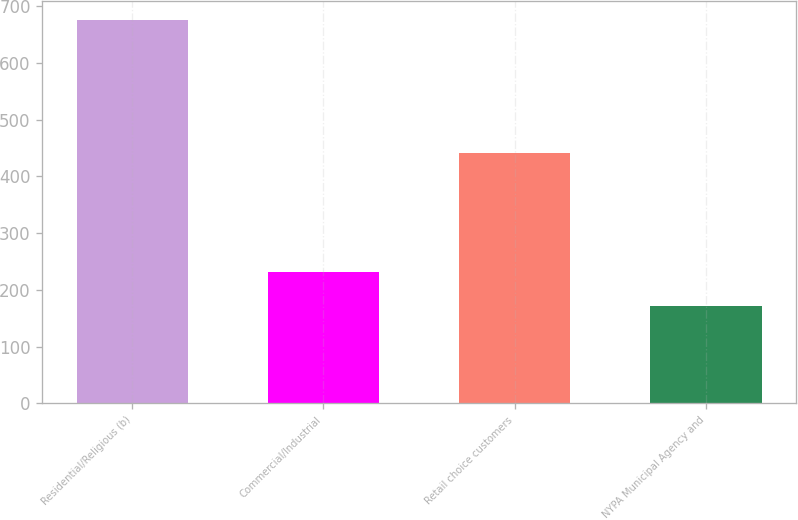Convert chart. <chart><loc_0><loc_0><loc_500><loc_500><bar_chart><fcel>Residential/Religious (b)<fcel>Commercial/Industrial<fcel>Retail choice customers<fcel>NYPA Municipal Agency and<nl><fcel>675<fcel>232<fcel>441<fcel>172<nl></chart> 